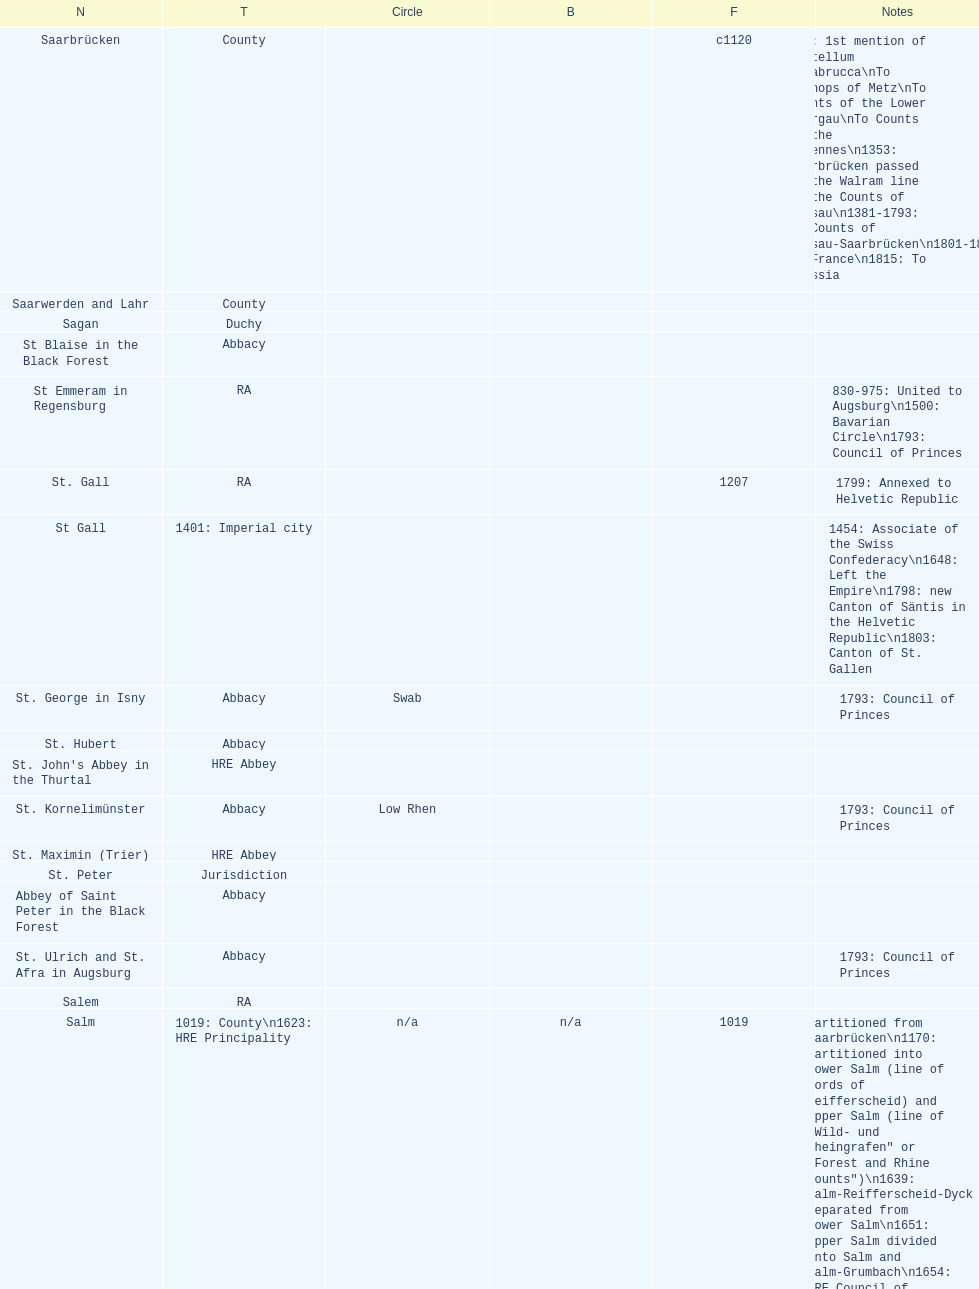How many states were of the same type as stuhlingen? 3. 